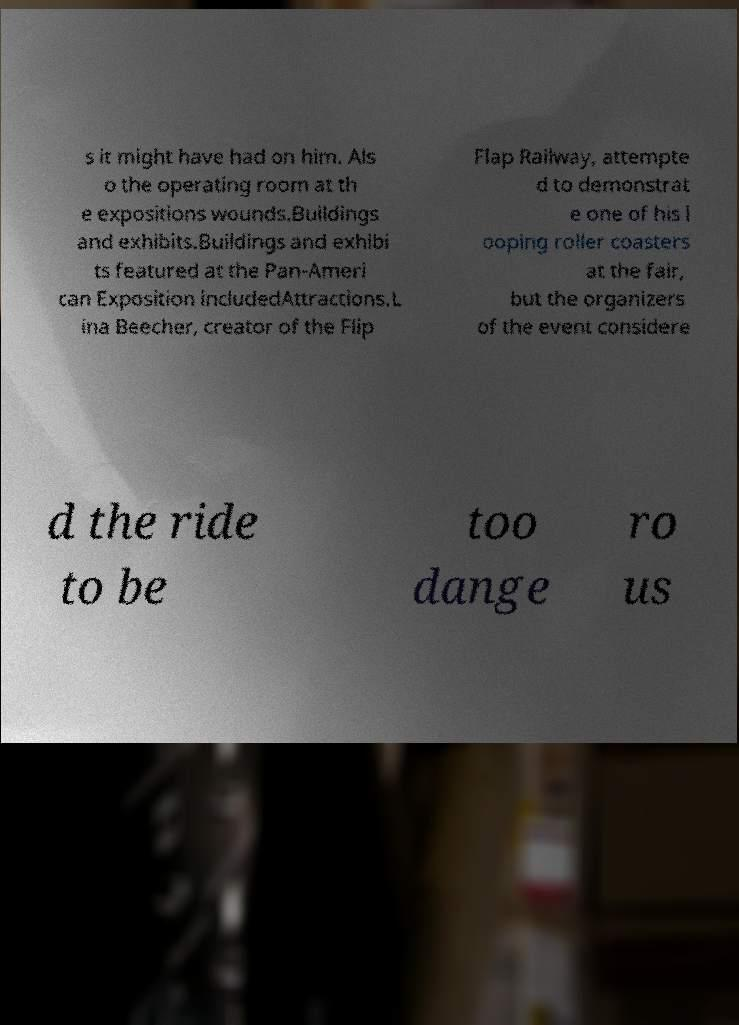Please identify and transcribe the text found in this image. s it might have had on him. Als o the operating room at th e expositions wounds.Buildings and exhibits.Buildings and exhibi ts featured at the Pan-Ameri can Exposition includedAttractions.L ina Beecher, creator of the Flip Flap Railway, attempte d to demonstrat e one of his l ooping roller coasters at the fair, but the organizers of the event considere d the ride to be too dange ro us 